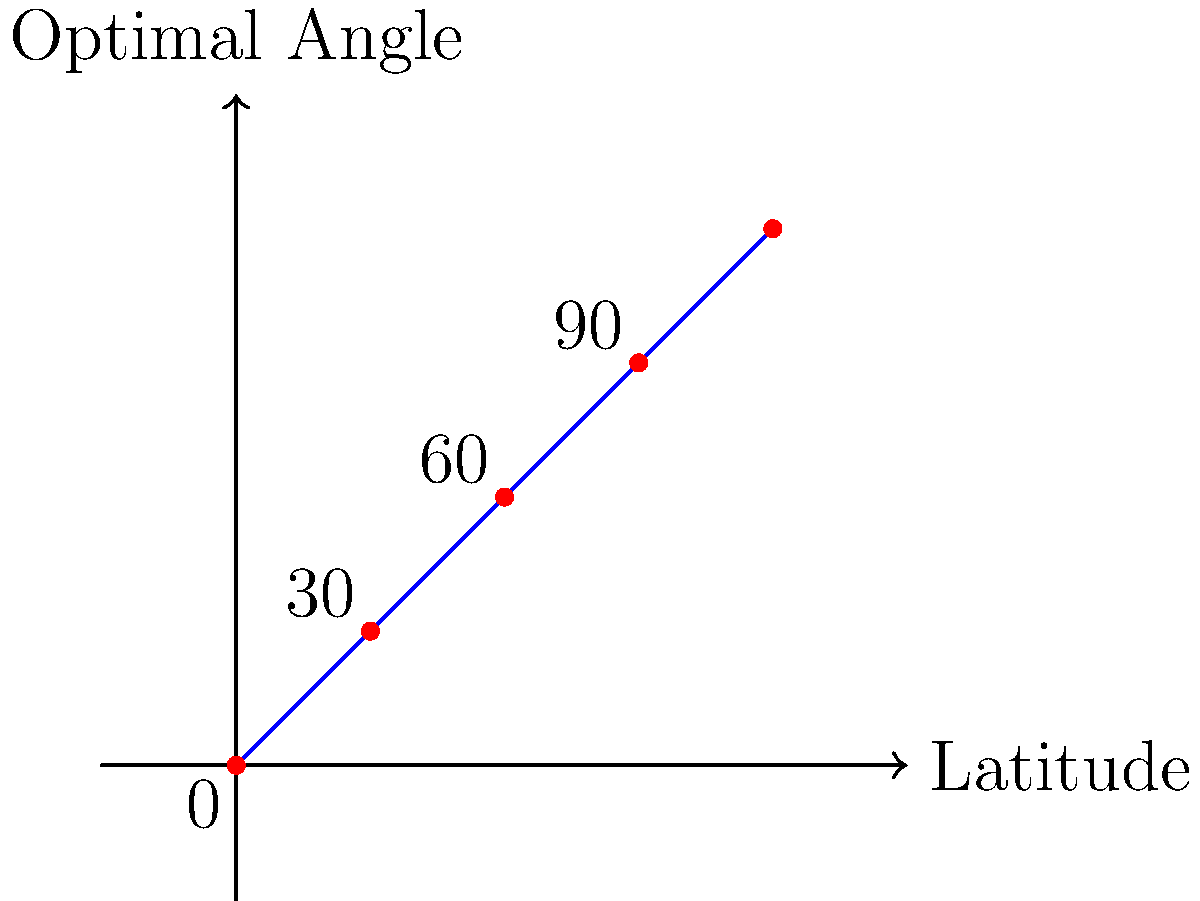As a tech startup founder with a background in high school physics, you're considering integrating solar panels into your company's new eco-friendly office building. Based on the graph showing the relationship between latitude and optimal solar panel angle, what would be the recommended tilt angle for solar panels if your office is located at a latitude of $45°$ North? To determine the optimal angle for solar panel installation based on latitude, we can follow these steps:

1. Understand the relationship: The graph shows a linear relationship between latitude and optimal panel angle.

2. Interpret the graph: The x-axis represents latitude, while the y-axis represents the optimal angle for solar panel tilt.

3. Observe the trend: As latitude increases, the optimal angle increases at a 1:1 ratio.

4. Identify the pattern: The optimal angle is approximately equal to the latitude.

5. Apply to the given latitude: For a latitude of $45°$ North:
   Optimal Angle $\approx$ Latitude
   Optimal Angle $\approx 45°$

6. Consider real-world adjustments: In practice, slight adjustments might be made for factors like local climate and seasonal variations, but $45°$ is a good starting point.

This simple rule (angle $\approx$ latitude) stems from the goal of maximizing direct sunlight exposure throughout the year, accounting for the Earth's tilt and orbit around the Sun.
Answer: $45°$ 